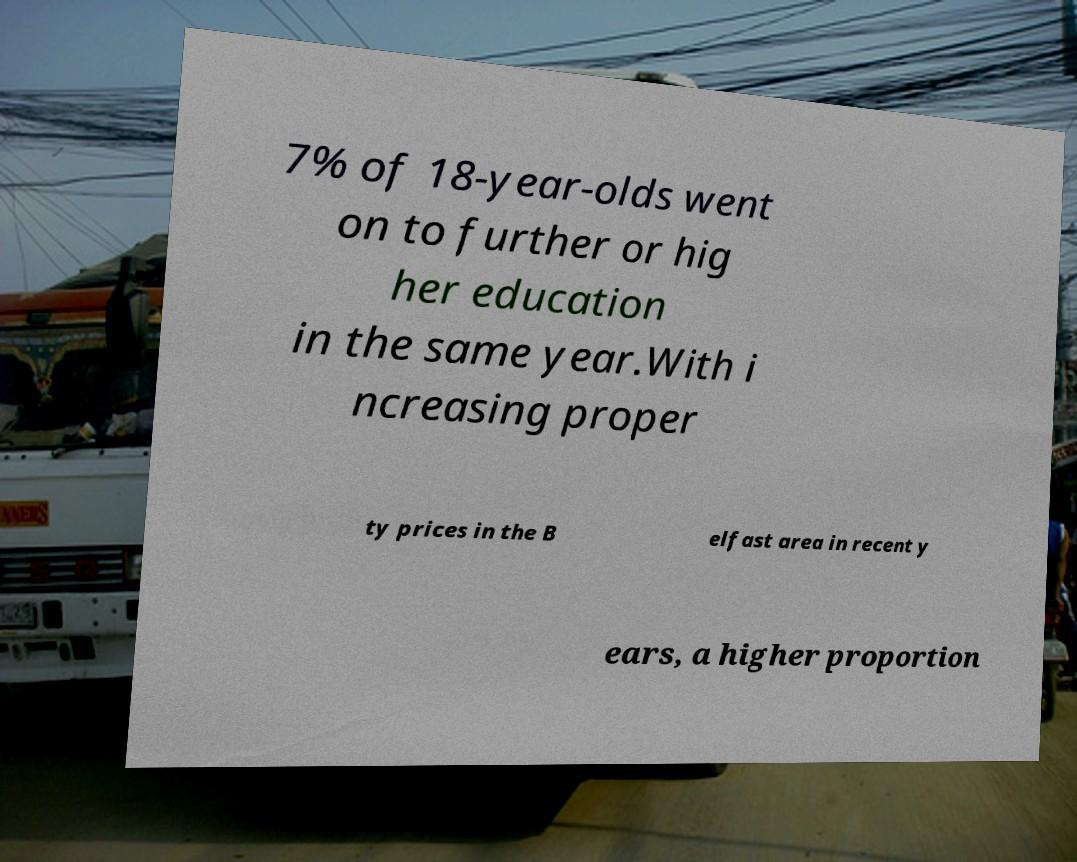I need the written content from this picture converted into text. Can you do that? 7% of 18-year-olds went on to further or hig her education in the same year.With i ncreasing proper ty prices in the B elfast area in recent y ears, a higher proportion 